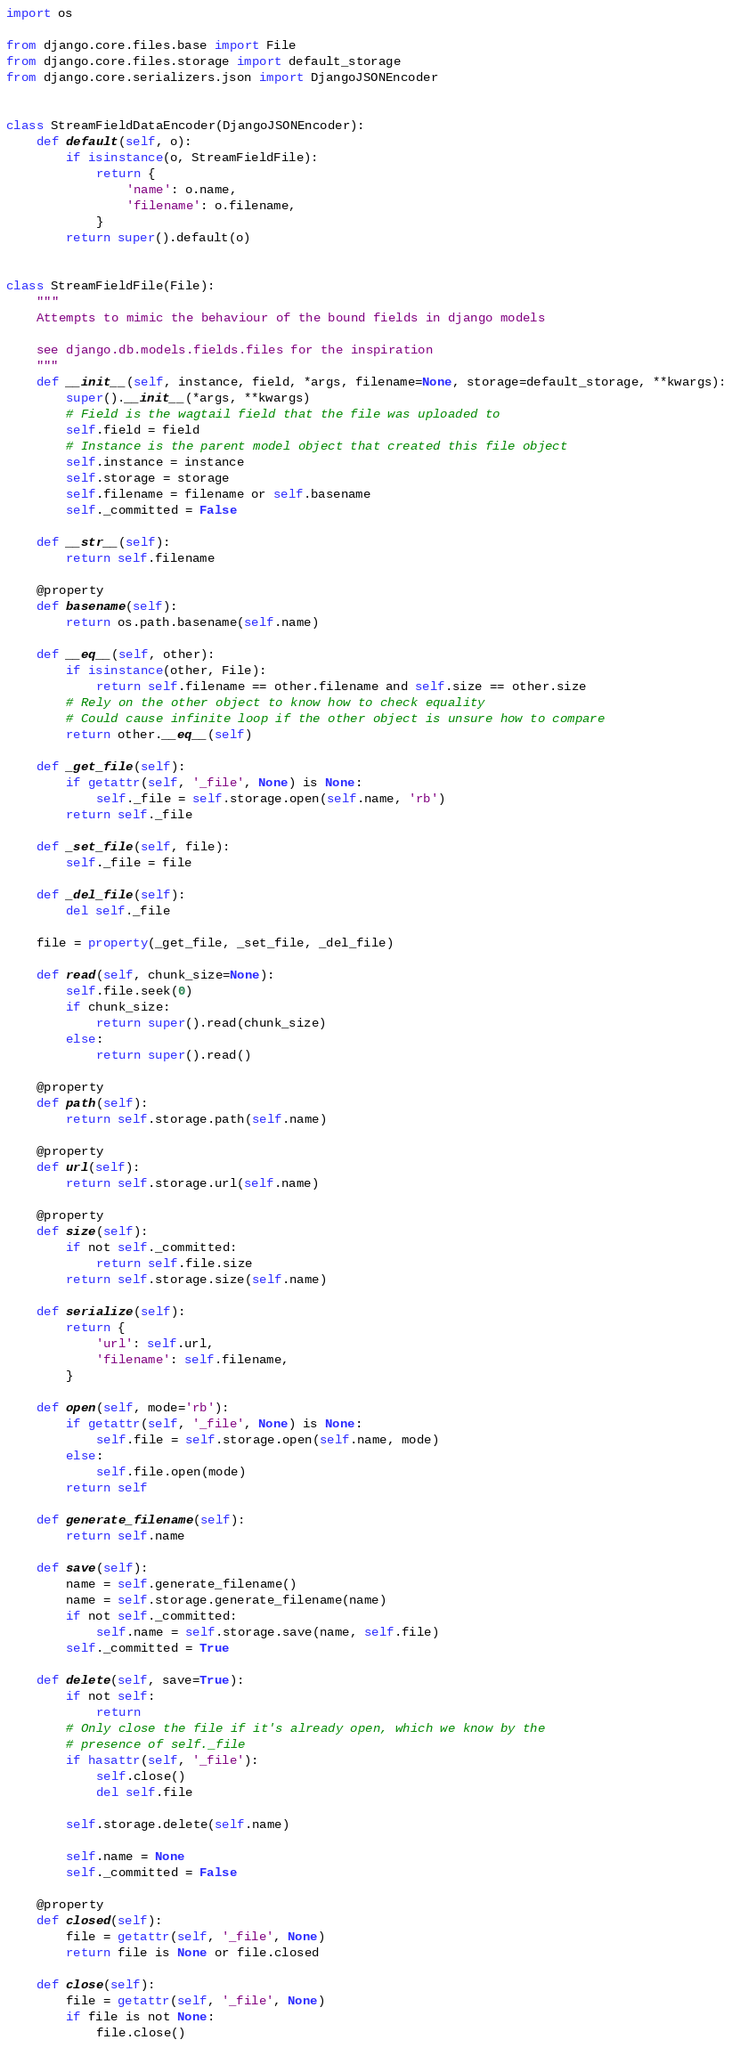Convert code to text. <code><loc_0><loc_0><loc_500><loc_500><_Python_>import os

from django.core.files.base import File
from django.core.files.storage import default_storage
from django.core.serializers.json import DjangoJSONEncoder


class StreamFieldDataEncoder(DjangoJSONEncoder):
    def default(self, o):
        if isinstance(o, StreamFieldFile):
            return {
                'name': o.name,
                'filename': o.filename,
            }
        return super().default(o)


class StreamFieldFile(File):
    """
    Attempts to mimic the behaviour of the bound fields in django models

    see django.db.models.fields.files for the inspiration
    """
    def __init__(self, instance, field, *args, filename=None, storage=default_storage, **kwargs):
        super().__init__(*args, **kwargs)
        # Field is the wagtail field that the file was uploaded to
        self.field = field
        # Instance is the parent model object that created this file object
        self.instance = instance
        self.storage = storage
        self.filename = filename or self.basename
        self._committed = False

    def __str__(self):
        return self.filename

    @property
    def basename(self):
        return os.path.basename(self.name)

    def __eq__(self, other):
        if isinstance(other, File):
            return self.filename == other.filename and self.size == other.size
        # Rely on the other object to know how to check equality
        # Could cause infinite loop if the other object is unsure how to compare
        return other.__eq__(self)

    def _get_file(self):
        if getattr(self, '_file', None) is None:
            self._file = self.storage.open(self.name, 'rb')
        return self._file

    def _set_file(self, file):
        self._file = file

    def _del_file(self):
        del self._file

    file = property(_get_file, _set_file, _del_file)

    def read(self, chunk_size=None):
        self.file.seek(0)
        if chunk_size:
            return super().read(chunk_size)
        else:
            return super().read()

    @property
    def path(self):
        return self.storage.path(self.name)

    @property
    def url(self):
        return self.storage.url(self.name)

    @property
    def size(self):
        if not self._committed:
            return self.file.size
        return self.storage.size(self.name)

    def serialize(self):
        return {
            'url': self.url,
            'filename': self.filename,
        }

    def open(self, mode='rb'):
        if getattr(self, '_file', None) is None:
            self.file = self.storage.open(self.name, mode)
        else:
            self.file.open(mode)
        return self

    def generate_filename(self):
        return self.name

    def save(self):
        name = self.generate_filename()
        name = self.storage.generate_filename(name)
        if not self._committed:
            self.name = self.storage.save(name, self.file)
        self._committed = True

    def delete(self, save=True):
        if not self:
            return
        # Only close the file if it's already open, which we know by the
        # presence of self._file
        if hasattr(self, '_file'):
            self.close()
            del self.file

        self.storage.delete(self.name)

        self.name = None
        self._committed = False

    @property
    def closed(self):
        file = getattr(self, '_file', None)
        return file is None or file.closed

    def close(self):
        file = getattr(self, '_file', None)
        if file is not None:
            file.close()
</code> 